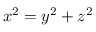Convert formula to latex. <formula><loc_0><loc_0><loc_500><loc_500>x ^ { 2 } = y ^ { 2 } + z ^ { 2 }</formula> 